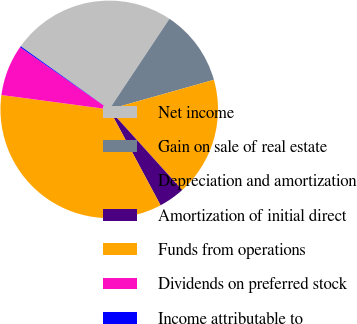Convert chart to OTSL. <chart><loc_0><loc_0><loc_500><loc_500><pie_chart><fcel>Net income<fcel>Gain on sale of real estate<fcel>Depreciation and amortization<fcel>Amortization of initial direct<fcel>Funds from operations<fcel>Dividends on preferred stock<fcel>Income attributable to<nl><fcel>24.48%<fcel>11.28%<fcel>17.68%<fcel>3.88%<fcel>34.93%<fcel>7.58%<fcel>0.17%<nl></chart> 